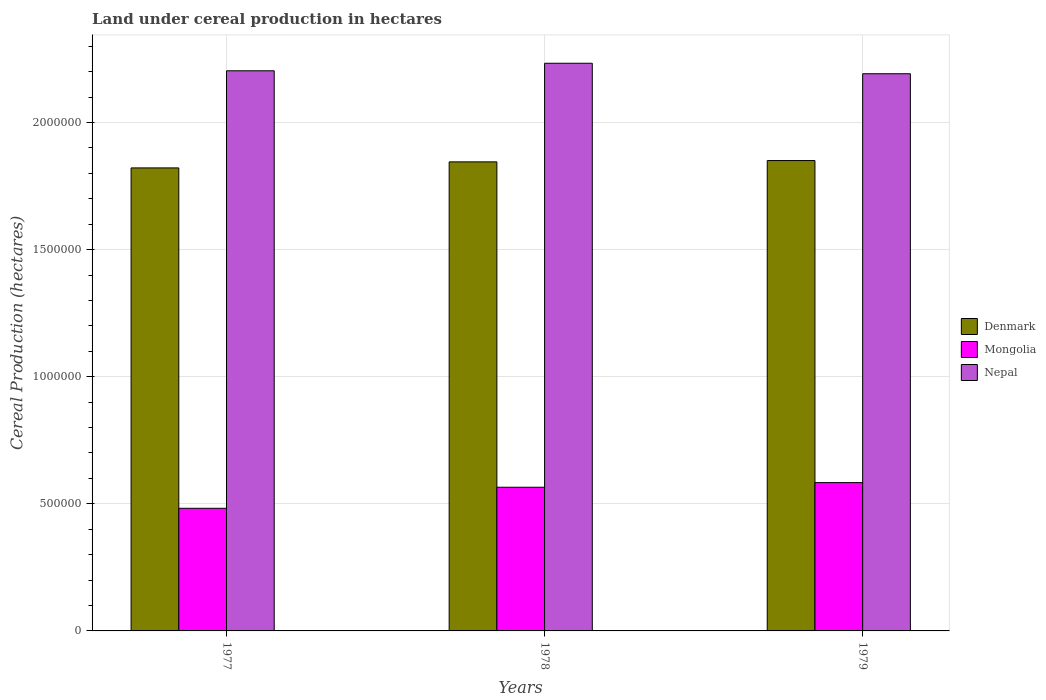Are the number of bars per tick equal to the number of legend labels?
Your response must be concise. Yes. Are the number of bars on each tick of the X-axis equal?
Provide a succinct answer. Yes. What is the label of the 3rd group of bars from the left?
Your answer should be very brief. 1979. What is the land under cereal production in Denmark in 1978?
Your response must be concise. 1.85e+06. Across all years, what is the maximum land under cereal production in Denmark?
Provide a short and direct response. 1.85e+06. Across all years, what is the minimum land under cereal production in Denmark?
Give a very brief answer. 1.82e+06. In which year was the land under cereal production in Nepal maximum?
Ensure brevity in your answer.  1978. What is the total land under cereal production in Mongolia in the graph?
Your response must be concise. 1.63e+06. What is the difference between the land under cereal production in Denmark in 1977 and that in 1978?
Keep it short and to the point. -2.38e+04. What is the difference between the land under cereal production in Denmark in 1977 and the land under cereal production in Mongolia in 1978?
Ensure brevity in your answer.  1.26e+06. What is the average land under cereal production in Denmark per year?
Your response must be concise. 1.84e+06. In the year 1977, what is the difference between the land under cereal production in Nepal and land under cereal production in Mongolia?
Provide a succinct answer. 1.72e+06. In how many years, is the land under cereal production in Mongolia greater than 1800000 hectares?
Keep it short and to the point. 0. What is the ratio of the land under cereal production in Denmark in 1977 to that in 1978?
Your answer should be compact. 0.99. Is the difference between the land under cereal production in Nepal in 1977 and 1978 greater than the difference between the land under cereal production in Mongolia in 1977 and 1978?
Ensure brevity in your answer.  Yes. What is the difference between the highest and the second highest land under cereal production in Nepal?
Offer a very short reply. 2.96e+04. What is the difference between the highest and the lowest land under cereal production in Mongolia?
Give a very brief answer. 1.01e+05. What does the 2nd bar from the left in 1977 represents?
Provide a succinct answer. Mongolia. What does the 3rd bar from the right in 1978 represents?
Provide a succinct answer. Denmark. How many bars are there?
Ensure brevity in your answer.  9. Are all the bars in the graph horizontal?
Provide a short and direct response. No. How many years are there in the graph?
Offer a very short reply. 3. Are the values on the major ticks of Y-axis written in scientific E-notation?
Your response must be concise. No. Does the graph contain any zero values?
Offer a terse response. No. What is the title of the graph?
Provide a succinct answer. Land under cereal production in hectares. What is the label or title of the Y-axis?
Provide a short and direct response. Cereal Production (hectares). What is the Cereal Production (hectares) in Denmark in 1977?
Make the answer very short. 1.82e+06. What is the Cereal Production (hectares) of Mongolia in 1977?
Provide a short and direct response. 4.82e+05. What is the Cereal Production (hectares) in Nepal in 1977?
Give a very brief answer. 2.20e+06. What is the Cereal Production (hectares) in Denmark in 1978?
Provide a short and direct response. 1.85e+06. What is the Cereal Production (hectares) of Mongolia in 1978?
Your answer should be compact. 5.65e+05. What is the Cereal Production (hectares) of Nepal in 1978?
Your answer should be very brief. 2.23e+06. What is the Cereal Production (hectares) of Denmark in 1979?
Your answer should be very brief. 1.85e+06. What is the Cereal Production (hectares) of Mongolia in 1979?
Your answer should be very brief. 5.83e+05. What is the Cereal Production (hectares) in Nepal in 1979?
Ensure brevity in your answer.  2.19e+06. Across all years, what is the maximum Cereal Production (hectares) in Denmark?
Offer a terse response. 1.85e+06. Across all years, what is the maximum Cereal Production (hectares) in Mongolia?
Keep it short and to the point. 5.83e+05. Across all years, what is the maximum Cereal Production (hectares) of Nepal?
Provide a short and direct response. 2.23e+06. Across all years, what is the minimum Cereal Production (hectares) in Denmark?
Keep it short and to the point. 1.82e+06. Across all years, what is the minimum Cereal Production (hectares) in Mongolia?
Provide a succinct answer. 4.82e+05. Across all years, what is the minimum Cereal Production (hectares) in Nepal?
Your answer should be compact. 2.19e+06. What is the total Cereal Production (hectares) in Denmark in the graph?
Your answer should be compact. 5.52e+06. What is the total Cereal Production (hectares) of Mongolia in the graph?
Ensure brevity in your answer.  1.63e+06. What is the total Cereal Production (hectares) in Nepal in the graph?
Your response must be concise. 6.63e+06. What is the difference between the Cereal Production (hectares) of Denmark in 1977 and that in 1978?
Your answer should be compact. -2.38e+04. What is the difference between the Cereal Production (hectares) in Mongolia in 1977 and that in 1978?
Provide a short and direct response. -8.28e+04. What is the difference between the Cereal Production (hectares) of Nepal in 1977 and that in 1978?
Keep it short and to the point. -2.96e+04. What is the difference between the Cereal Production (hectares) in Denmark in 1977 and that in 1979?
Offer a terse response. -2.89e+04. What is the difference between the Cereal Production (hectares) of Mongolia in 1977 and that in 1979?
Provide a succinct answer. -1.01e+05. What is the difference between the Cereal Production (hectares) in Nepal in 1977 and that in 1979?
Make the answer very short. 1.16e+04. What is the difference between the Cereal Production (hectares) in Denmark in 1978 and that in 1979?
Ensure brevity in your answer.  -5145. What is the difference between the Cereal Production (hectares) of Mongolia in 1978 and that in 1979?
Ensure brevity in your answer.  -1.82e+04. What is the difference between the Cereal Production (hectares) of Nepal in 1978 and that in 1979?
Offer a terse response. 4.12e+04. What is the difference between the Cereal Production (hectares) of Denmark in 1977 and the Cereal Production (hectares) of Mongolia in 1978?
Offer a terse response. 1.26e+06. What is the difference between the Cereal Production (hectares) in Denmark in 1977 and the Cereal Production (hectares) in Nepal in 1978?
Keep it short and to the point. -4.12e+05. What is the difference between the Cereal Production (hectares) of Mongolia in 1977 and the Cereal Production (hectares) of Nepal in 1978?
Provide a short and direct response. -1.75e+06. What is the difference between the Cereal Production (hectares) of Denmark in 1977 and the Cereal Production (hectares) of Mongolia in 1979?
Make the answer very short. 1.24e+06. What is the difference between the Cereal Production (hectares) in Denmark in 1977 and the Cereal Production (hectares) in Nepal in 1979?
Provide a short and direct response. -3.70e+05. What is the difference between the Cereal Production (hectares) of Mongolia in 1977 and the Cereal Production (hectares) of Nepal in 1979?
Keep it short and to the point. -1.71e+06. What is the difference between the Cereal Production (hectares) in Denmark in 1978 and the Cereal Production (hectares) in Mongolia in 1979?
Provide a short and direct response. 1.26e+06. What is the difference between the Cereal Production (hectares) of Denmark in 1978 and the Cereal Production (hectares) of Nepal in 1979?
Offer a terse response. -3.47e+05. What is the difference between the Cereal Production (hectares) in Mongolia in 1978 and the Cereal Production (hectares) in Nepal in 1979?
Your answer should be compact. -1.63e+06. What is the average Cereal Production (hectares) in Denmark per year?
Your answer should be compact. 1.84e+06. What is the average Cereal Production (hectares) of Mongolia per year?
Your answer should be compact. 5.44e+05. What is the average Cereal Production (hectares) in Nepal per year?
Offer a very short reply. 2.21e+06. In the year 1977, what is the difference between the Cereal Production (hectares) of Denmark and Cereal Production (hectares) of Mongolia?
Give a very brief answer. 1.34e+06. In the year 1977, what is the difference between the Cereal Production (hectares) in Denmark and Cereal Production (hectares) in Nepal?
Your answer should be very brief. -3.82e+05. In the year 1977, what is the difference between the Cereal Production (hectares) in Mongolia and Cereal Production (hectares) in Nepal?
Your response must be concise. -1.72e+06. In the year 1978, what is the difference between the Cereal Production (hectares) in Denmark and Cereal Production (hectares) in Mongolia?
Your answer should be compact. 1.28e+06. In the year 1978, what is the difference between the Cereal Production (hectares) in Denmark and Cereal Production (hectares) in Nepal?
Your answer should be compact. -3.88e+05. In the year 1978, what is the difference between the Cereal Production (hectares) of Mongolia and Cereal Production (hectares) of Nepal?
Keep it short and to the point. -1.67e+06. In the year 1979, what is the difference between the Cereal Production (hectares) in Denmark and Cereal Production (hectares) in Mongolia?
Provide a succinct answer. 1.27e+06. In the year 1979, what is the difference between the Cereal Production (hectares) of Denmark and Cereal Production (hectares) of Nepal?
Offer a very short reply. -3.42e+05. In the year 1979, what is the difference between the Cereal Production (hectares) of Mongolia and Cereal Production (hectares) of Nepal?
Your answer should be very brief. -1.61e+06. What is the ratio of the Cereal Production (hectares) in Denmark in 1977 to that in 1978?
Keep it short and to the point. 0.99. What is the ratio of the Cereal Production (hectares) in Mongolia in 1977 to that in 1978?
Make the answer very short. 0.85. What is the ratio of the Cereal Production (hectares) in Nepal in 1977 to that in 1978?
Offer a terse response. 0.99. What is the ratio of the Cereal Production (hectares) of Denmark in 1977 to that in 1979?
Keep it short and to the point. 0.98. What is the ratio of the Cereal Production (hectares) in Mongolia in 1977 to that in 1979?
Provide a succinct answer. 0.83. What is the ratio of the Cereal Production (hectares) of Nepal in 1977 to that in 1979?
Offer a very short reply. 1.01. What is the ratio of the Cereal Production (hectares) in Mongolia in 1978 to that in 1979?
Make the answer very short. 0.97. What is the ratio of the Cereal Production (hectares) of Nepal in 1978 to that in 1979?
Offer a very short reply. 1.02. What is the difference between the highest and the second highest Cereal Production (hectares) of Denmark?
Ensure brevity in your answer.  5145. What is the difference between the highest and the second highest Cereal Production (hectares) of Mongolia?
Provide a succinct answer. 1.82e+04. What is the difference between the highest and the second highest Cereal Production (hectares) in Nepal?
Your answer should be compact. 2.96e+04. What is the difference between the highest and the lowest Cereal Production (hectares) in Denmark?
Give a very brief answer. 2.89e+04. What is the difference between the highest and the lowest Cereal Production (hectares) of Mongolia?
Ensure brevity in your answer.  1.01e+05. What is the difference between the highest and the lowest Cereal Production (hectares) of Nepal?
Ensure brevity in your answer.  4.12e+04. 